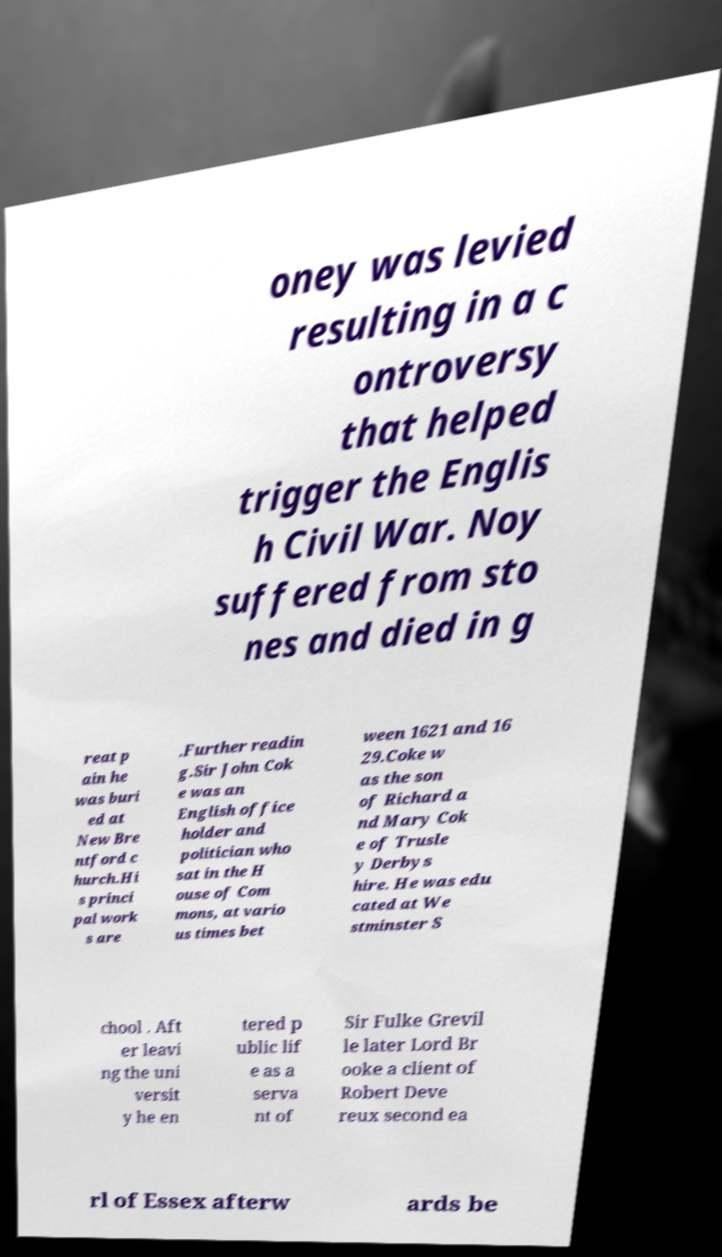Could you assist in decoding the text presented in this image and type it out clearly? oney was levied resulting in a c ontroversy that helped trigger the Englis h Civil War. Noy suffered from sto nes and died in g reat p ain he was buri ed at New Bre ntford c hurch.Hi s princi pal work s are .Further readin g.Sir John Cok e was an English office holder and politician who sat in the H ouse of Com mons, at vario us times bet ween 1621 and 16 29.Coke w as the son of Richard a nd Mary Cok e of Trusle y Derbys hire. He was edu cated at We stminster S chool . Aft er leavi ng the uni versit y he en tered p ublic lif e as a serva nt of Sir Fulke Grevil le later Lord Br ooke a client of Robert Deve reux second ea rl of Essex afterw ards be 